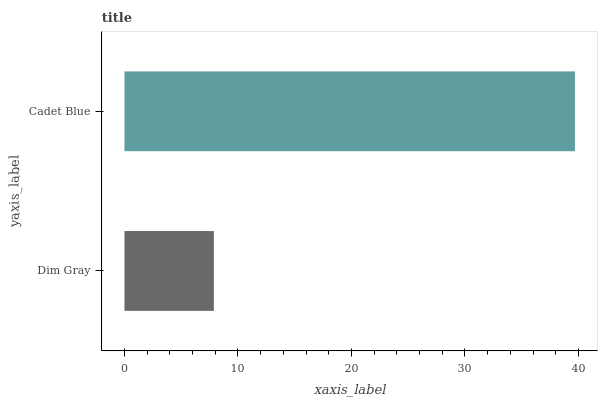Is Dim Gray the minimum?
Answer yes or no. Yes. Is Cadet Blue the maximum?
Answer yes or no. Yes. Is Cadet Blue the minimum?
Answer yes or no. No. Is Cadet Blue greater than Dim Gray?
Answer yes or no. Yes. Is Dim Gray less than Cadet Blue?
Answer yes or no. Yes. Is Dim Gray greater than Cadet Blue?
Answer yes or no. No. Is Cadet Blue less than Dim Gray?
Answer yes or no. No. Is Cadet Blue the high median?
Answer yes or no. Yes. Is Dim Gray the low median?
Answer yes or no. Yes. Is Dim Gray the high median?
Answer yes or no. No. Is Cadet Blue the low median?
Answer yes or no. No. 